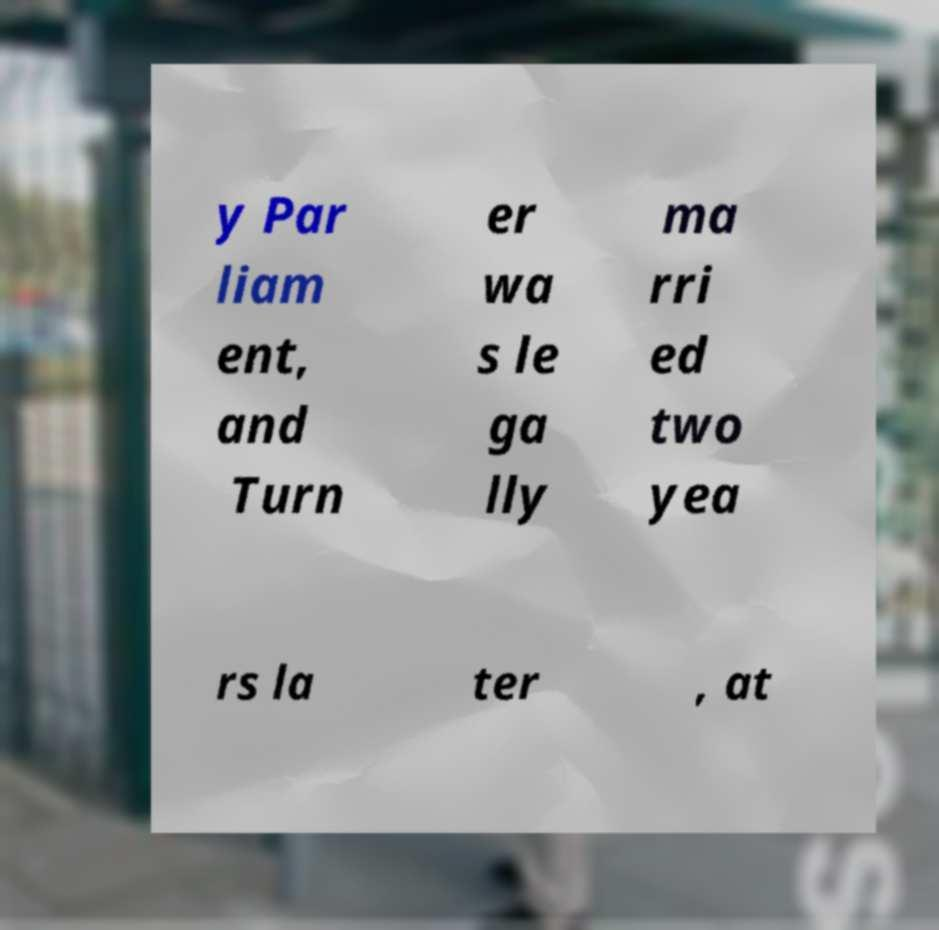Can you accurately transcribe the text from the provided image for me? y Par liam ent, and Turn er wa s le ga lly ma rri ed two yea rs la ter , at 